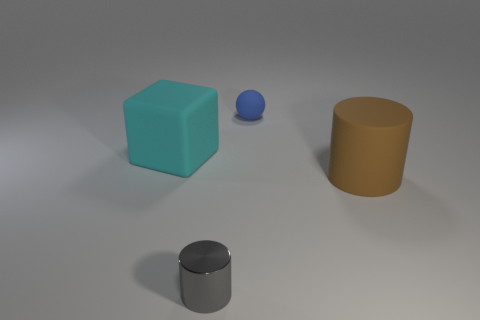Is there any other thing that is the same shape as the tiny blue matte object?
Your answer should be compact. No. What number of brown rubber objects are there?
Your answer should be compact. 1. There is a rubber sphere; how many gray shiny things are on the left side of it?
Offer a very short reply. 1. Is there a big brown matte object that has the same shape as the tiny gray shiny thing?
Give a very brief answer. Yes. Is the material of the thing that is to the left of the gray thing the same as the tiny object that is to the right of the tiny gray object?
Keep it short and to the point. Yes. There is a matte object in front of the big rubber thing left of the rubber thing that is behind the cyan rubber block; how big is it?
Your response must be concise. Large. What is the material of the block that is the same size as the brown cylinder?
Give a very brief answer. Rubber. Are there any blue balls of the same size as the gray cylinder?
Give a very brief answer. Yes. Do the tiny metallic object and the brown rubber object have the same shape?
Ensure brevity in your answer.  Yes. Are there any tiny objects that are behind the cylinder in front of the large matte object that is in front of the large rubber cube?
Your answer should be compact. Yes. 